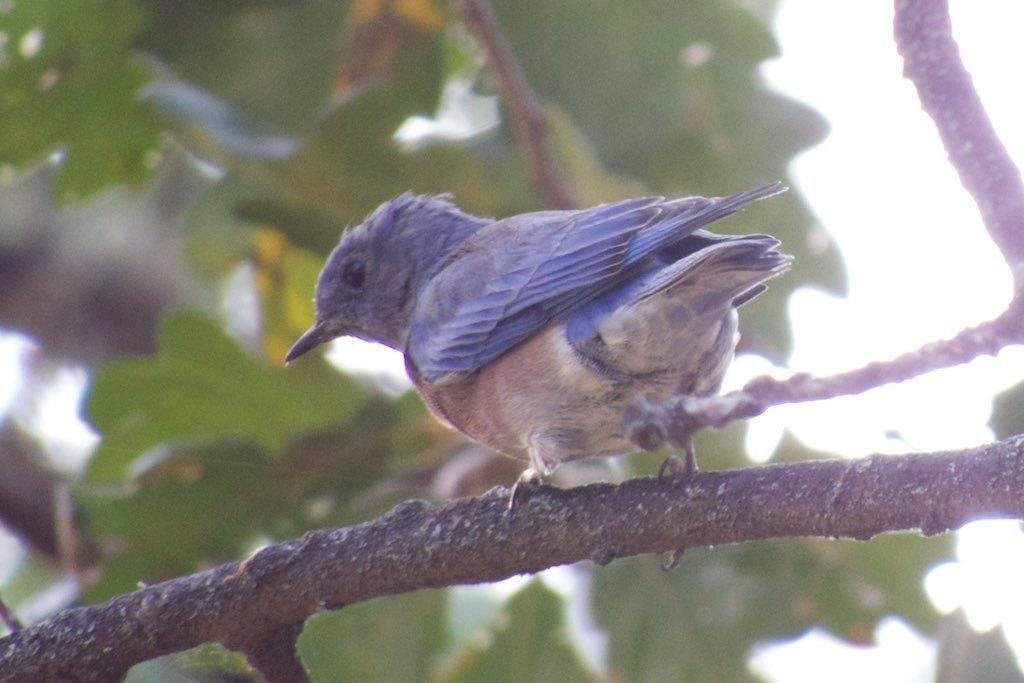What type of animal can be seen in the image? There is a bird in the image. What is the bird standing on? The bird is standing on a stem. What can be seen in the background of the image? Trees and the sky are visible in the background of the image. What type of fire can be seen in the image? There is no fire present in the image; it features a bird standing on a stem with trees and the sky visible in the background. 